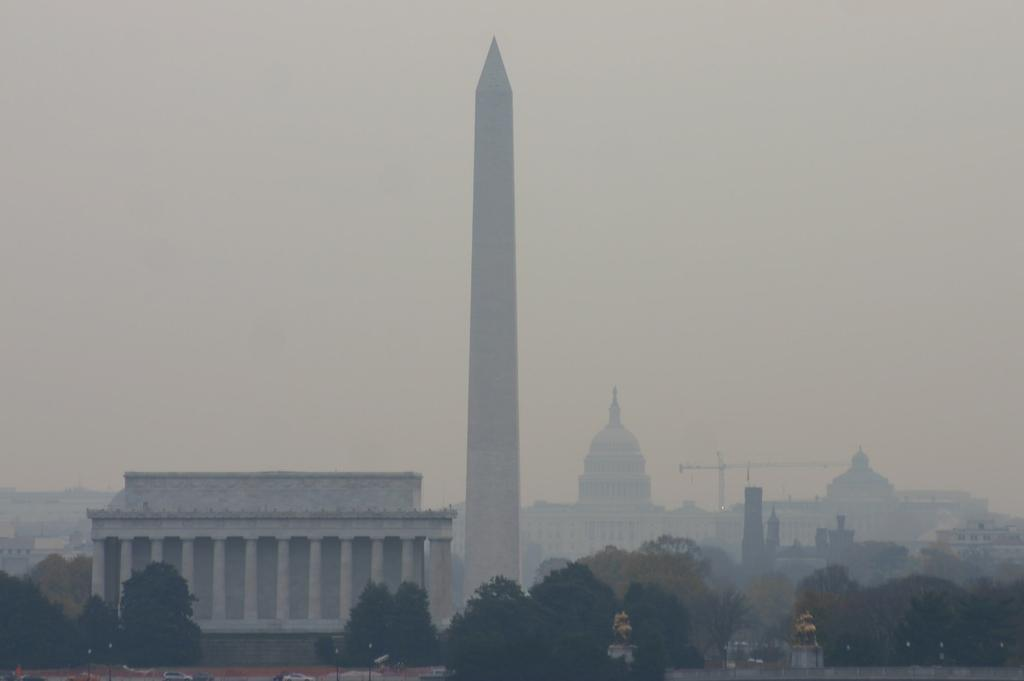What is the main structure in the middle of the picture? There is a tall pillar in the middle of the picture. What type of vegetation is present at the bottom of the picture? There are trees at the bottom of the picture. What can be seen in the background of the picture? The sky is visible in the background of the picture. What type of furniture can be seen in the alley next to the tall pillar? There is no alley or furniture present in the image; it only features a tall pillar, trees, and the sky. 